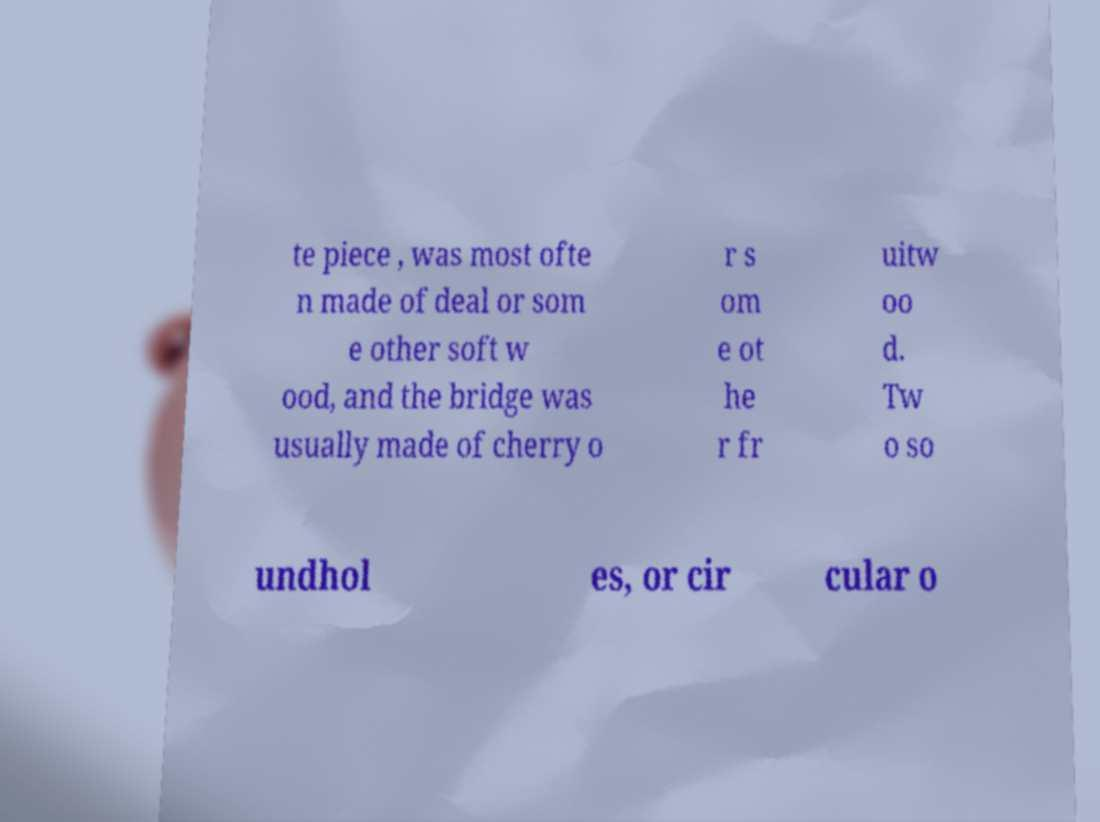Could you assist in decoding the text presented in this image and type it out clearly? te piece , was most ofte n made of deal or som e other soft w ood, and the bridge was usually made of cherry o r s om e ot he r fr uitw oo d. Tw o so undhol es, or cir cular o 